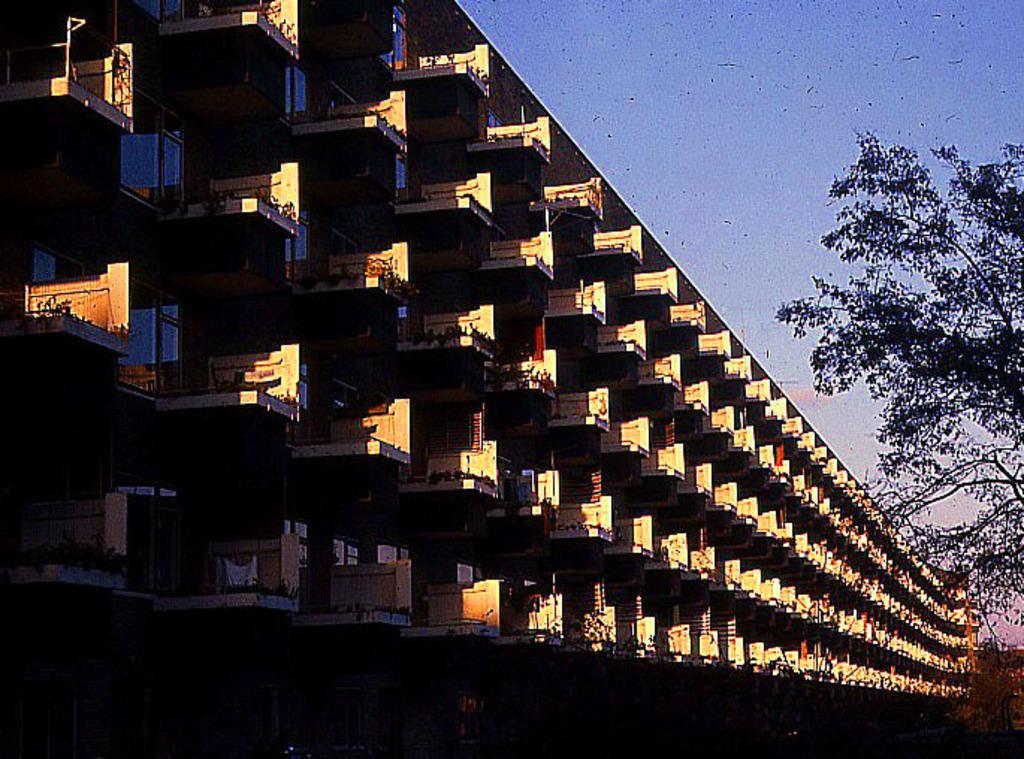What type of structure is visible in the picture? There is a building in the picture. What other natural elements can be seen in the picture? There are trees in the picture. How would you describe the weather based on the sky in the picture? The sky is clear in the picture, suggesting good weather. Where is the oven located in the picture? There is no oven present in the picture. How many toads can be seen in the picture? There are no toads present in the picture. 